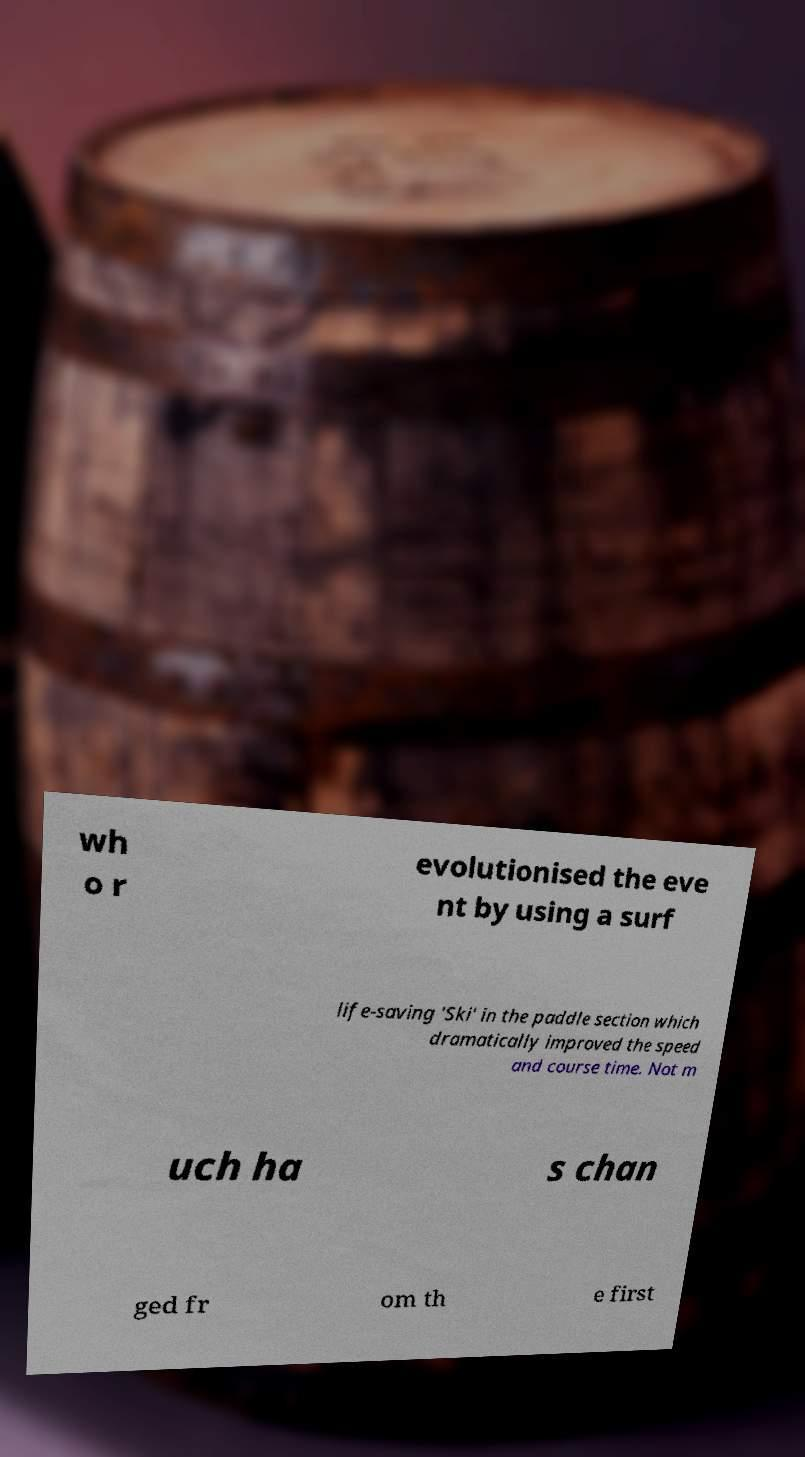Please read and relay the text visible in this image. What does it say? wh o r evolutionised the eve nt by using a surf life-saving 'Ski' in the paddle section which dramatically improved the speed and course time. Not m uch ha s chan ged fr om th e first 